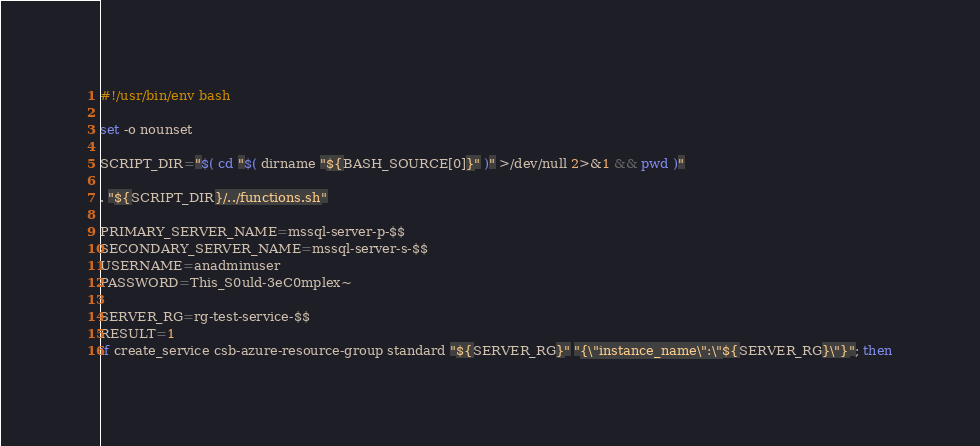<code> <loc_0><loc_0><loc_500><loc_500><_Bash_>#!/usr/bin/env bash

set -o nounset

SCRIPT_DIR="$( cd "$( dirname "${BASH_SOURCE[0]}" )" >/dev/null 2>&1 && pwd )"

. "${SCRIPT_DIR}/../functions.sh"

PRIMARY_SERVER_NAME=mssql-server-p-$$
SECONDARY_SERVER_NAME=mssql-server-s-$$
USERNAME=anadminuser
PASSWORD=This_S0uld-3eC0mplex~

SERVER_RG=rg-test-service-$$
RESULT=1
if create_service csb-azure-resource-group standard "${SERVER_RG}" "{\"instance_name\":\"${SERVER_RG}\"}"; then</code> 